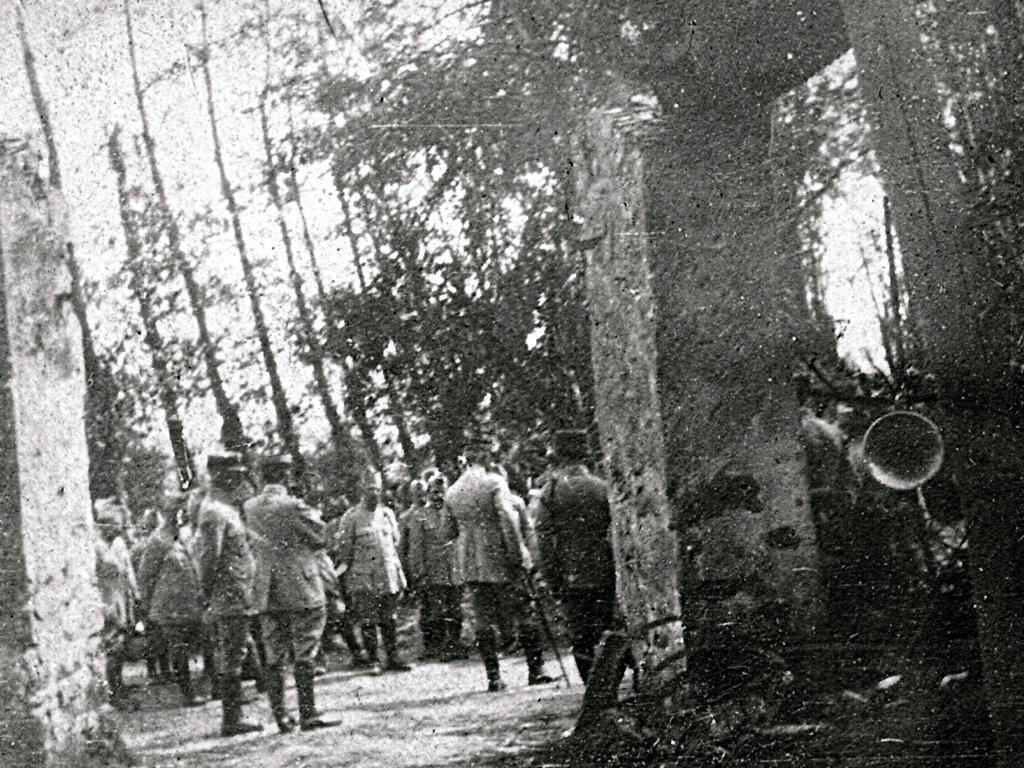What is the color scheme of the image? The image is black and white. What are the people in the image doing? The people are standing on the ground in the image. What are the people wearing? The people are wearing uniforms. What can be seen in the background of the image? There are trees and pillars in the background of the image. What type of butter is being spread on the jelly in the image? There is no butter or jelly present in the image. Can you see any wings on the people in the image? No, there are no wings visible on the people in the image. 